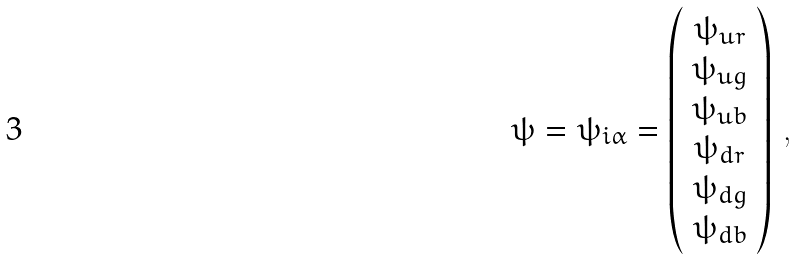Convert formula to latex. <formula><loc_0><loc_0><loc_500><loc_500>\psi = \psi _ { i \alpha } = \left ( \begin{array} { c } \psi _ { u r } \\ \psi _ { u g } \\ \psi _ { u b } \\ \psi _ { d r } \\ \psi _ { d g } \\ \psi _ { d b } \end{array} \right ) \, ,</formula> 